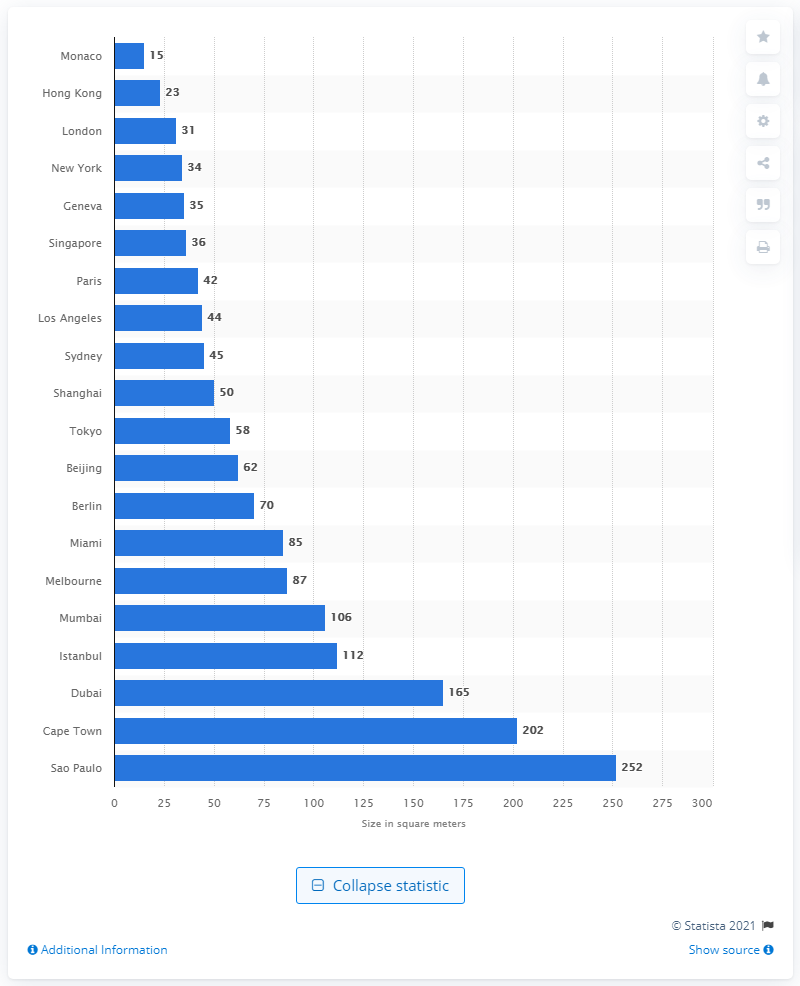Mention a couple of crucial points in this snapshot. In 2020, one million dollars could have purchased approximately 15 square meters of luxury property in Monaco. 